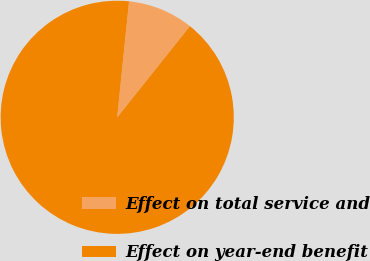Convert chart to OTSL. <chart><loc_0><loc_0><loc_500><loc_500><pie_chart><fcel>Effect on total service and<fcel>Effect on year-end benefit<nl><fcel>9.09%<fcel>90.91%<nl></chart> 